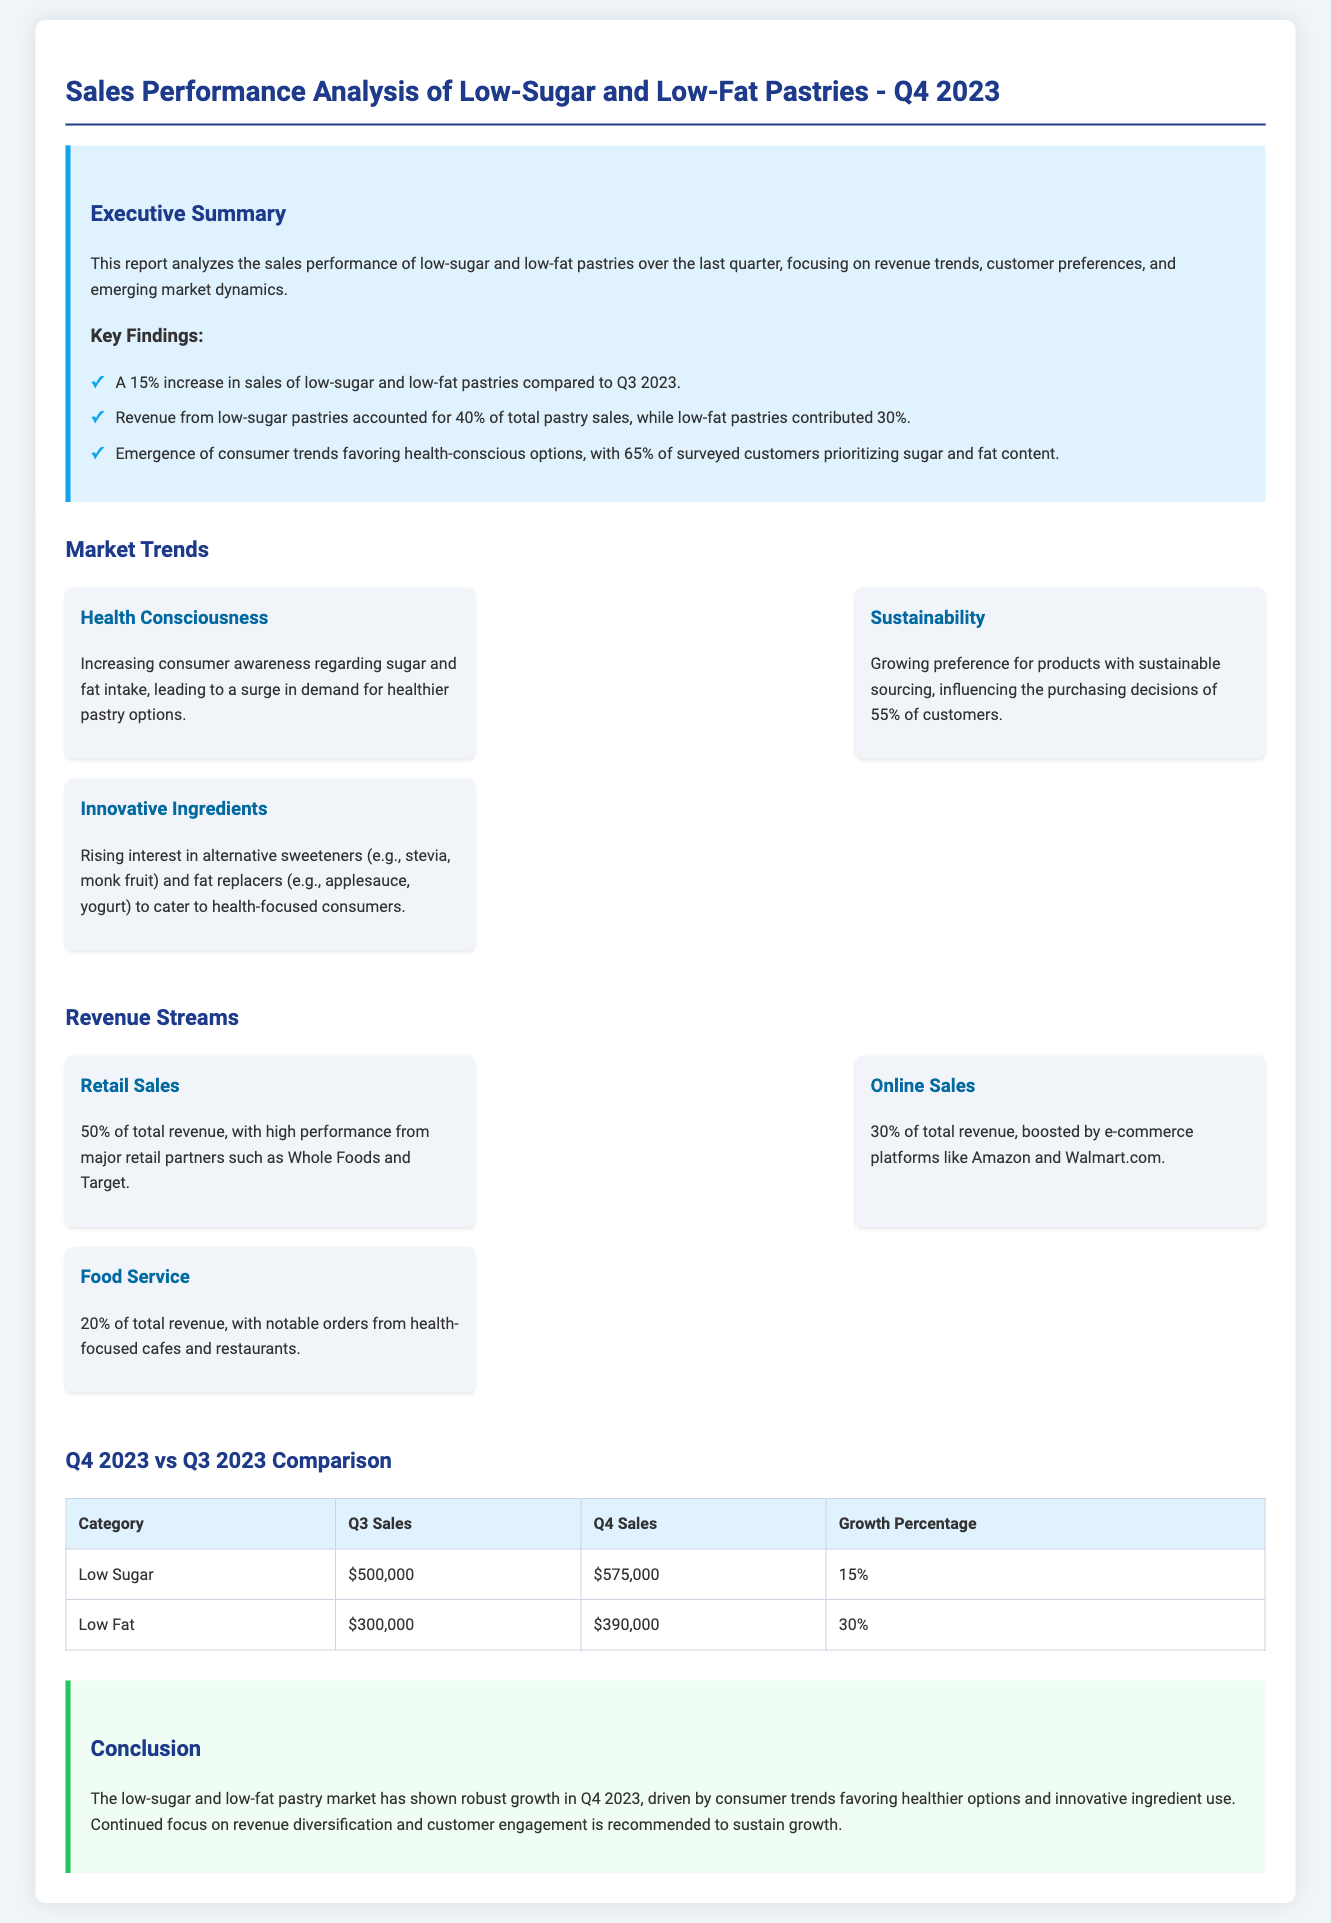What was the sales growth percentage of low-fat pastries from Q3 to Q4 2023? The document states that the sales of low-fat pastries increased by 30% from Q3 to Q4 2023.
Answer: 30% What percentage of total pastry sales did low-sugar pastries contribute? The report indicates that low-sugar pastries accounted for 40% of total pastry sales.
Answer: 40% Which revenue stream accounts for the highest percentage of total revenue? The document reveals that retail sales make up 50% of total revenue, which is the highest among the revenue streams.
Answer: 50% What is the total revenue contribution of low-fat pastries in Q4 2023? For Q4 2023, low-fat pastry sales are reported to be $390,000.
Answer: $390,000 How many percent of customers prioritize sugar and fat content according to the survey? The report indicates that 65% of surveyed customers prioritize sugar and fat content.
Answer: 65% What is the revenue contribution of food service to total revenue? Food service contributes 20% to the total revenue, as per the document.
Answer: 20% What innovative ingredient trends are mentioned in the report? The document mentions interest in alternative sweeteners and fat replacers as innovative ingredient trends.
Answer: Alternative sweeteners and fat replacers What is the sales figure for low-sugar pastries in Q4 2023? The stated sales figure for low-sugar pastries in Q4 2023 is $575,000.
Answer: $575,000 What emerging trend is highlighted concerning sustainability? The report emphasizes a growing preference for products with sustainable sourcing affecting the purchasing decisions of 55% of customers.
Answer: 55% 